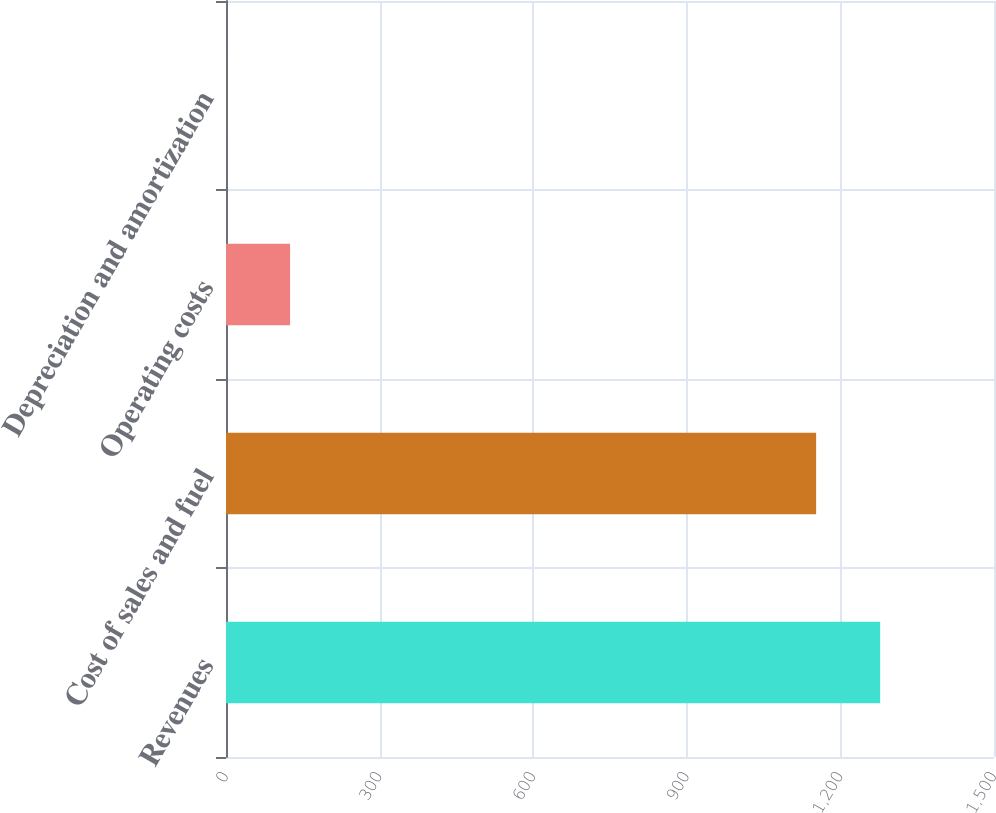Convert chart to OTSL. <chart><loc_0><loc_0><loc_500><loc_500><bar_chart><fcel>Revenues<fcel>Cost of sales and fuel<fcel>Operating costs<fcel>Depreciation and amortization<nl><fcel>1277.65<fcel>1152.6<fcel>125.15<fcel>0.1<nl></chart> 